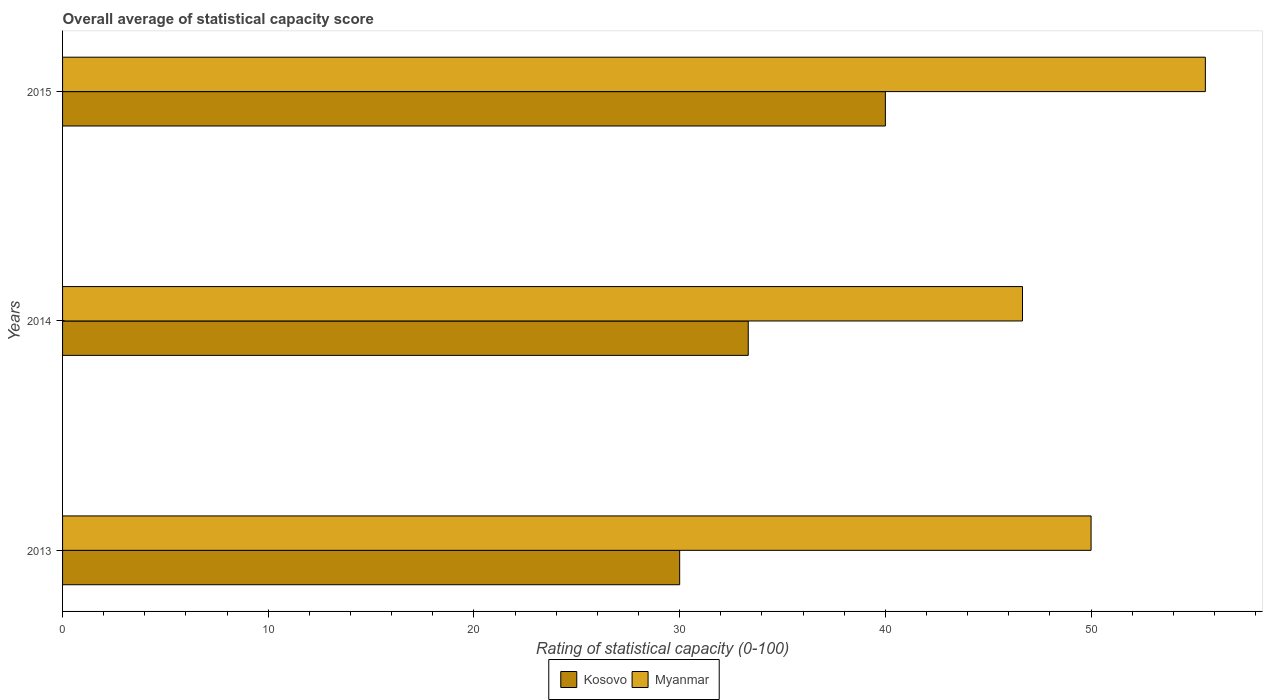How many different coloured bars are there?
Offer a terse response. 2. How many groups of bars are there?
Your answer should be very brief. 3. How many bars are there on the 2nd tick from the bottom?
Provide a short and direct response. 2. What is the label of the 3rd group of bars from the top?
Make the answer very short. 2013. In how many cases, is the number of bars for a given year not equal to the number of legend labels?
Make the answer very short. 0. What is the rating of statistical capacity in Myanmar in 2015?
Your answer should be very brief. 55.56. Across all years, what is the maximum rating of statistical capacity in Myanmar?
Keep it short and to the point. 55.56. Across all years, what is the minimum rating of statistical capacity in Kosovo?
Make the answer very short. 30. In which year was the rating of statistical capacity in Kosovo maximum?
Your response must be concise. 2015. What is the total rating of statistical capacity in Myanmar in the graph?
Provide a succinct answer. 152.22. What is the difference between the rating of statistical capacity in Myanmar in 2013 and that in 2015?
Keep it short and to the point. -5.56. What is the difference between the rating of statistical capacity in Myanmar in 2014 and the rating of statistical capacity in Kosovo in 2013?
Keep it short and to the point. 16.67. What is the average rating of statistical capacity in Kosovo per year?
Ensure brevity in your answer.  34.44. In how many years, is the rating of statistical capacity in Kosovo greater than 44 ?
Your answer should be compact. 0. What is the ratio of the rating of statistical capacity in Myanmar in 2013 to that in 2014?
Keep it short and to the point. 1.07. What is the difference between the highest and the second highest rating of statistical capacity in Myanmar?
Your answer should be compact. 5.56. What is the difference between the highest and the lowest rating of statistical capacity in Kosovo?
Your answer should be compact. 10. What does the 1st bar from the top in 2014 represents?
Provide a succinct answer. Myanmar. What does the 2nd bar from the bottom in 2014 represents?
Give a very brief answer. Myanmar. What is the difference between two consecutive major ticks on the X-axis?
Your answer should be compact. 10. How many legend labels are there?
Offer a very short reply. 2. What is the title of the graph?
Give a very brief answer. Overall average of statistical capacity score. What is the label or title of the X-axis?
Offer a terse response. Rating of statistical capacity (0-100). What is the label or title of the Y-axis?
Offer a very short reply. Years. What is the Rating of statistical capacity (0-100) of Kosovo in 2014?
Ensure brevity in your answer.  33.33. What is the Rating of statistical capacity (0-100) in Myanmar in 2014?
Provide a succinct answer. 46.67. What is the Rating of statistical capacity (0-100) in Kosovo in 2015?
Offer a very short reply. 40. What is the Rating of statistical capacity (0-100) in Myanmar in 2015?
Give a very brief answer. 55.56. Across all years, what is the maximum Rating of statistical capacity (0-100) in Myanmar?
Make the answer very short. 55.56. Across all years, what is the minimum Rating of statistical capacity (0-100) of Myanmar?
Your answer should be compact. 46.67. What is the total Rating of statistical capacity (0-100) in Kosovo in the graph?
Offer a terse response. 103.33. What is the total Rating of statistical capacity (0-100) in Myanmar in the graph?
Your response must be concise. 152.22. What is the difference between the Rating of statistical capacity (0-100) in Kosovo in 2013 and that in 2014?
Your answer should be very brief. -3.33. What is the difference between the Rating of statistical capacity (0-100) of Myanmar in 2013 and that in 2014?
Your answer should be very brief. 3.33. What is the difference between the Rating of statistical capacity (0-100) of Myanmar in 2013 and that in 2015?
Provide a short and direct response. -5.56. What is the difference between the Rating of statistical capacity (0-100) in Kosovo in 2014 and that in 2015?
Your answer should be compact. -6.67. What is the difference between the Rating of statistical capacity (0-100) of Myanmar in 2014 and that in 2015?
Your answer should be very brief. -8.89. What is the difference between the Rating of statistical capacity (0-100) of Kosovo in 2013 and the Rating of statistical capacity (0-100) of Myanmar in 2014?
Your answer should be compact. -16.67. What is the difference between the Rating of statistical capacity (0-100) in Kosovo in 2013 and the Rating of statistical capacity (0-100) in Myanmar in 2015?
Give a very brief answer. -25.56. What is the difference between the Rating of statistical capacity (0-100) in Kosovo in 2014 and the Rating of statistical capacity (0-100) in Myanmar in 2015?
Provide a short and direct response. -22.22. What is the average Rating of statistical capacity (0-100) of Kosovo per year?
Provide a succinct answer. 34.44. What is the average Rating of statistical capacity (0-100) in Myanmar per year?
Ensure brevity in your answer.  50.74. In the year 2014, what is the difference between the Rating of statistical capacity (0-100) of Kosovo and Rating of statistical capacity (0-100) of Myanmar?
Provide a succinct answer. -13.33. In the year 2015, what is the difference between the Rating of statistical capacity (0-100) in Kosovo and Rating of statistical capacity (0-100) in Myanmar?
Provide a succinct answer. -15.56. What is the ratio of the Rating of statistical capacity (0-100) in Myanmar in 2013 to that in 2014?
Your answer should be compact. 1.07. What is the ratio of the Rating of statistical capacity (0-100) in Myanmar in 2013 to that in 2015?
Your answer should be compact. 0.9. What is the ratio of the Rating of statistical capacity (0-100) in Myanmar in 2014 to that in 2015?
Offer a terse response. 0.84. What is the difference between the highest and the second highest Rating of statistical capacity (0-100) of Myanmar?
Give a very brief answer. 5.56. What is the difference between the highest and the lowest Rating of statistical capacity (0-100) of Myanmar?
Your response must be concise. 8.89. 